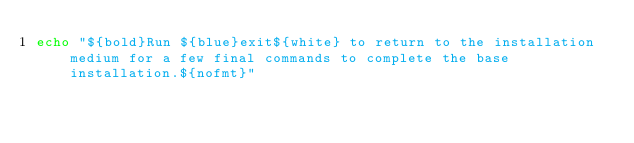<code> <loc_0><loc_0><loc_500><loc_500><_Bash_>echo "${bold}Run ${blue}exit${white} to return to the installation medium for a few final commands to complete the base installation.${nofmt}"
</code> 